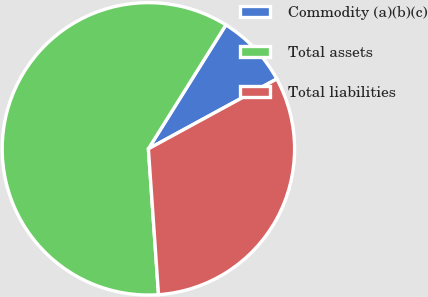Convert chart to OTSL. <chart><loc_0><loc_0><loc_500><loc_500><pie_chart><fcel>Commodity (a)(b)(c)<fcel>Total assets<fcel>Total liabilities<nl><fcel>8.17%<fcel>60.0%<fcel>31.83%<nl></chart> 